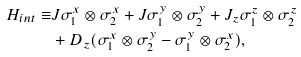<formula> <loc_0><loc_0><loc_500><loc_500>H _ { i n t } \equiv & J \sigma _ { 1 } ^ { x } \otimes \sigma _ { 2 } ^ { x } + J \sigma _ { 1 } ^ { y } \otimes \sigma _ { 2 } ^ { y } + J _ { z } \sigma _ { 1 } ^ { z } \otimes \sigma _ { 2 } ^ { z } \\ & + D _ { z } ( \sigma _ { 1 } ^ { x } \otimes \sigma _ { 2 } ^ { y } - \sigma _ { 1 } ^ { y } \otimes \sigma _ { 2 } ^ { x } ) ,</formula> 